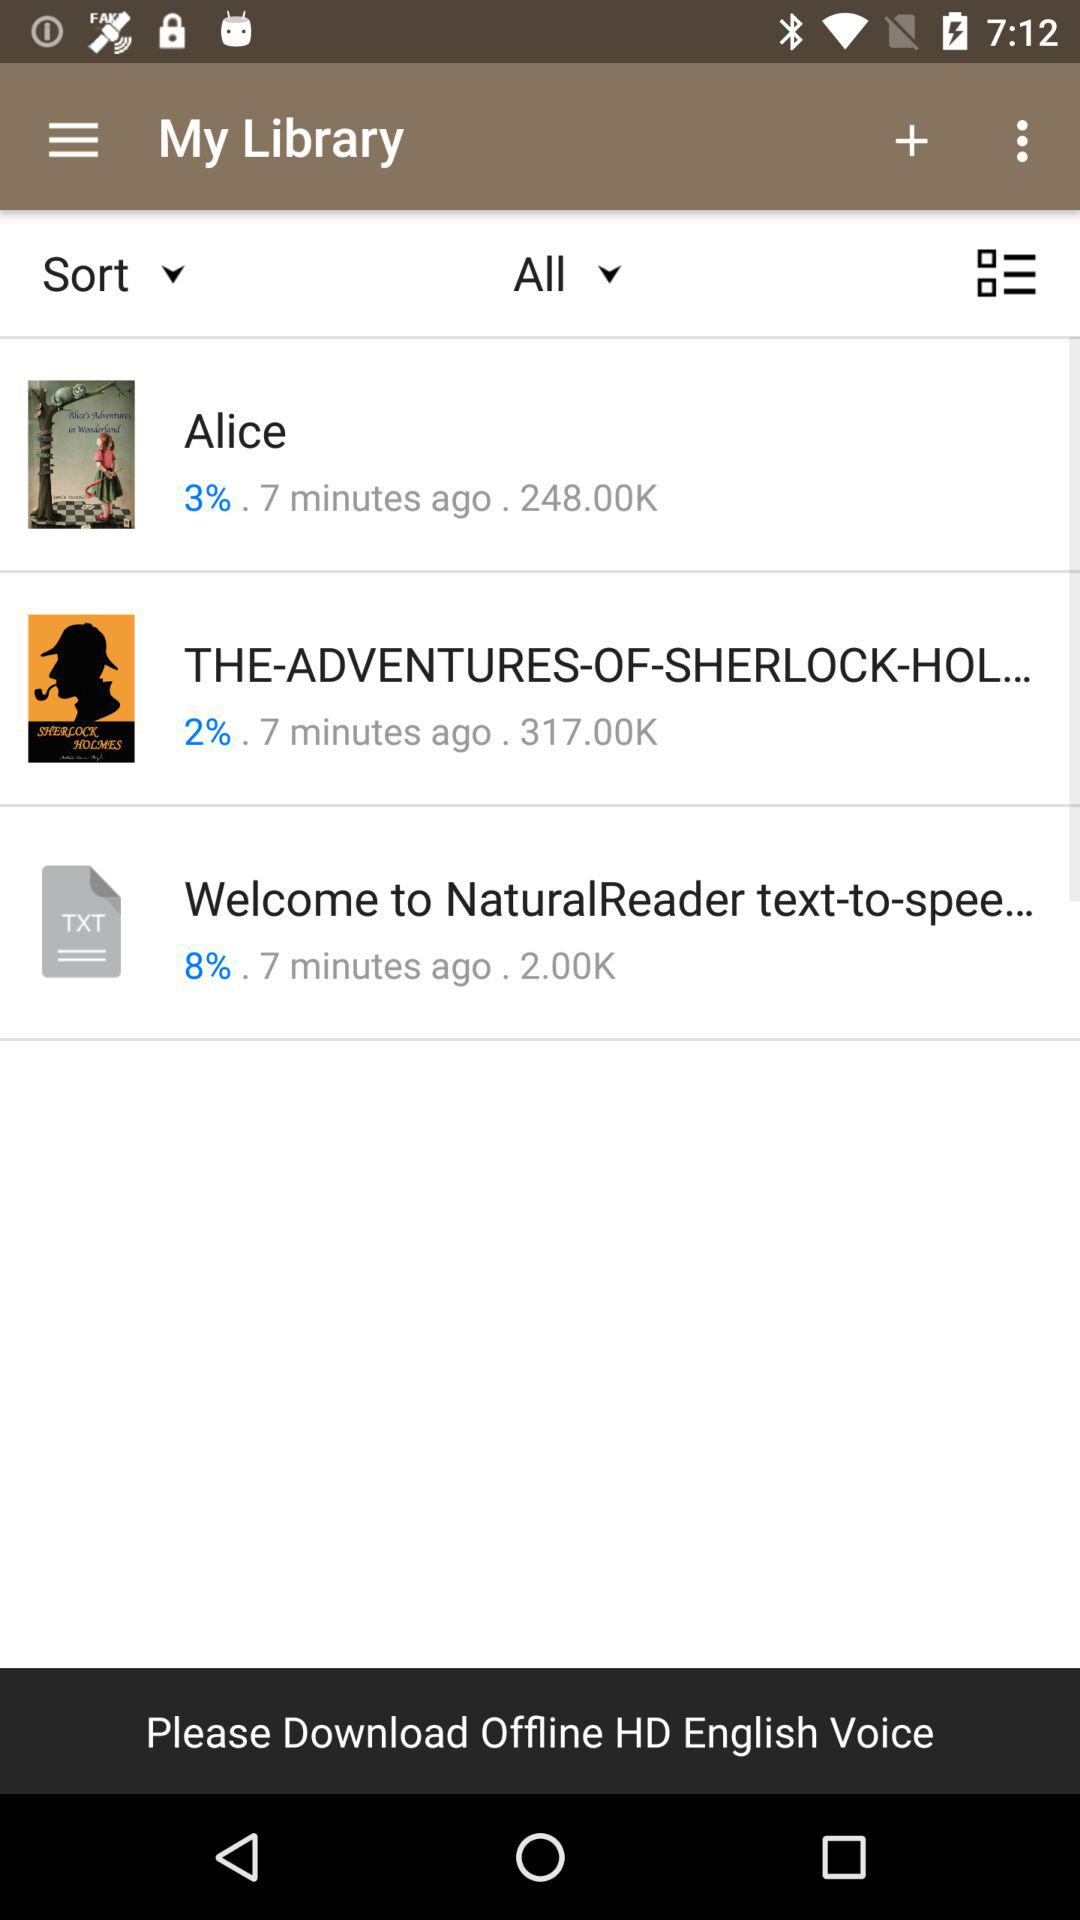What memory has been given for Alice? The given memory is 248.00KB. 